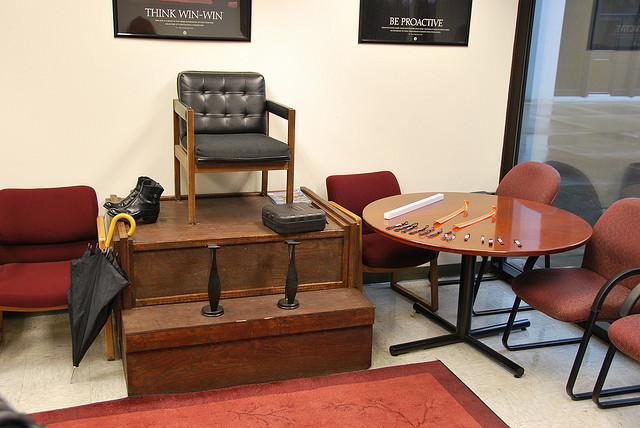What color is the theme of this room?
Concise answer only. Red. Is it a rainy day?
Short answer required. Yes. Is this room to torture people?
Give a very brief answer. No. 